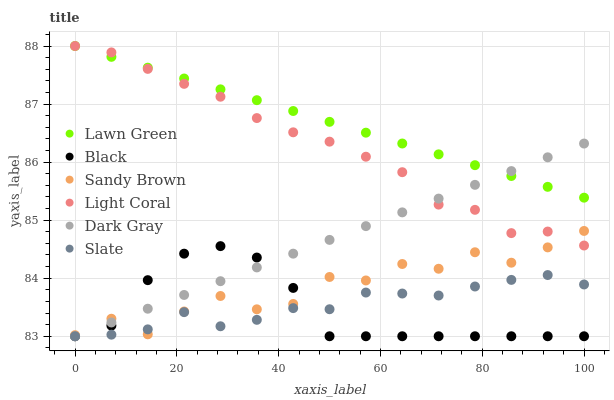Does Black have the minimum area under the curve?
Answer yes or no. Yes. Does Lawn Green have the maximum area under the curve?
Answer yes or no. Yes. Does Slate have the minimum area under the curve?
Answer yes or no. No. Does Slate have the maximum area under the curve?
Answer yes or no. No. Is Dark Gray the smoothest?
Answer yes or no. Yes. Is Sandy Brown the roughest?
Answer yes or no. Yes. Is Slate the smoothest?
Answer yes or no. No. Is Slate the roughest?
Answer yes or no. No. Does Slate have the lowest value?
Answer yes or no. Yes. Does Light Coral have the lowest value?
Answer yes or no. No. Does Light Coral have the highest value?
Answer yes or no. Yes. Does Dark Gray have the highest value?
Answer yes or no. No. Is Sandy Brown less than Lawn Green?
Answer yes or no. Yes. Is Lawn Green greater than Sandy Brown?
Answer yes or no. Yes. Does Sandy Brown intersect Slate?
Answer yes or no. Yes. Is Sandy Brown less than Slate?
Answer yes or no. No. Is Sandy Brown greater than Slate?
Answer yes or no. No. Does Sandy Brown intersect Lawn Green?
Answer yes or no. No. 